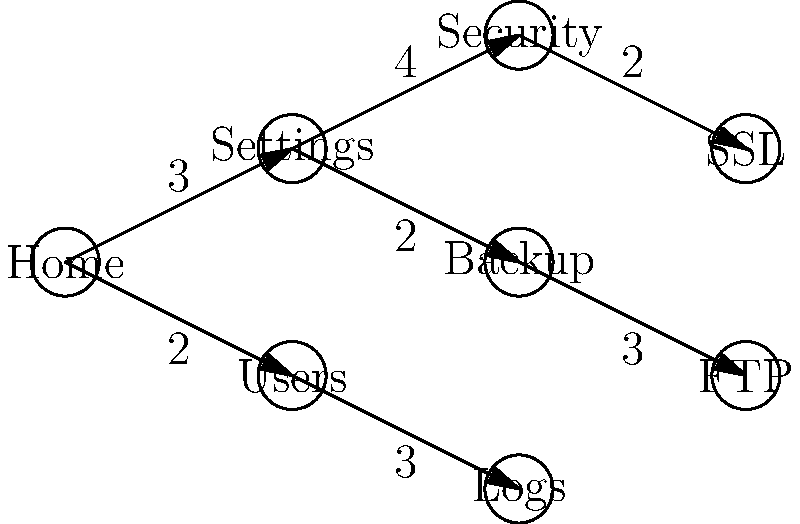In the Hepsia control panel's menu structure shown above, each node represents a page, and the edges represent navigation paths with their corresponding time costs (in seconds). A user needs to access the SSL settings page from the Home page. What is the shortest time (in seconds) it would take for the user to navigate to the SSL page, and what is the optimal path? To solve this problem, we'll use Dijkstra's shortest path algorithm:

1. Start at the Home node with a distance of 0.
2. Explore neighboring nodes:
   - Settings: distance = 3
   - Users: distance = 2
3. Choose Users (shortest distance).
4. Explore Users' neighbors:
   - Logs: distance = 2 + 3 = 5
5. Return to Settings (next shortest distance).
6. Explore Settings' neighbors:
   - Security: distance = 3 + 4 = 7
   - Backup: distance = 3 + 2 = 5
7. Choose Backup (shortest unexplored distance).
8. Explore Backup's neighbors:
   - FTP: distance = 5 + 3 = 8
9. Return to Security (next shortest distance).
10. Explore Security's neighbors:
    - SSL: distance = 7 + 2 = 9

The shortest path is Home -> Settings -> Security -> SSL, with a total time of 9 seconds.
Answer: 9 seconds; Home -> Settings -> Security -> SSL 